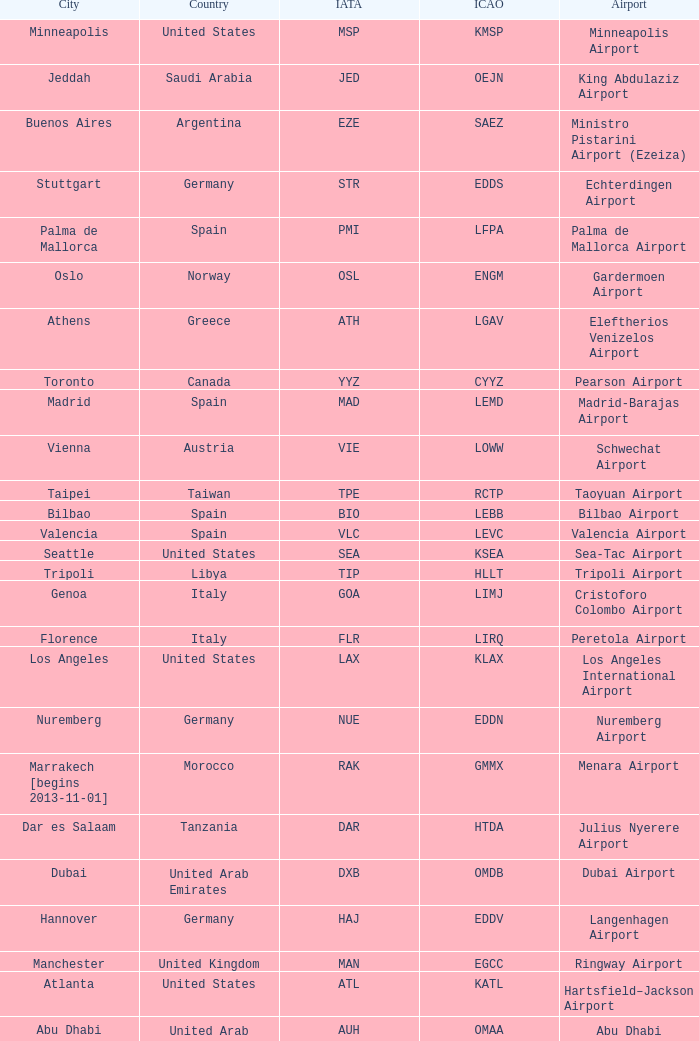Parse the full table. {'header': ['City', 'Country', 'IATA', 'ICAO', 'Airport'], 'rows': [['Minneapolis', 'United States', 'MSP', 'KMSP', 'Minneapolis Airport'], ['Jeddah', 'Saudi Arabia', 'JED', 'OEJN', 'King Abdulaziz Airport'], ['Buenos Aires', 'Argentina', 'EZE', 'SAEZ', 'Ministro Pistarini Airport (Ezeiza)'], ['Stuttgart', 'Germany', 'STR', 'EDDS', 'Echterdingen Airport'], ['Palma de Mallorca', 'Spain', 'PMI', 'LFPA', 'Palma de Mallorca Airport'], ['Oslo', 'Norway', 'OSL', 'ENGM', 'Gardermoen Airport'], ['Athens', 'Greece', 'ATH', 'LGAV', 'Eleftherios Venizelos Airport'], ['Toronto', 'Canada', 'YYZ', 'CYYZ', 'Pearson Airport'], ['Madrid', 'Spain', 'MAD', 'LEMD', 'Madrid-Barajas Airport'], ['Vienna', 'Austria', 'VIE', 'LOWW', 'Schwechat Airport'], ['Taipei', 'Taiwan', 'TPE', 'RCTP', 'Taoyuan Airport'], ['Bilbao', 'Spain', 'BIO', 'LEBB', 'Bilbao Airport'], ['Valencia', 'Spain', 'VLC', 'LEVC', 'Valencia Airport'], ['Seattle', 'United States', 'SEA', 'KSEA', 'Sea-Tac Airport'], ['Tripoli', 'Libya', 'TIP', 'HLLT', 'Tripoli Airport'], ['Genoa', 'Italy', 'GOA', 'LIMJ', 'Cristoforo Colombo Airport'], ['Florence', 'Italy', 'FLR', 'LIRQ', 'Peretola Airport'], ['Los Angeles', 'United States', 'LAX', 'KLAX', 'Los Angeles International Airport'], ['Nuremberg', 'Germany', 'NUE', 'EDDN', 'Nuremberg Airport'], ['Marrakech [begins 2013-11-01]', 'Morocco', 'RAK', 'GMMX', 'Menara Airport'], ['Dar es Salaam', 'Tanzania', 'DAR', 'HTDA', 'Julius Nyerere Airport'], ['Dubai', 'United Arab Emirates', 'DXB', 'OMDB', 'Dubai Airport'], ['Hannover', 'Germany', 'HAJ', 'EDDV', 'Langenhagen Airport'], ['Manchester', 'United Kingdom', 'MAN', 'EGCC', 'Ringway Airport'], ['Atlanta', 'United States', 'ATL', 'KATL', 'Hartsfield–Jackson Airport'], ['Abu Dhabi', 'United Arab Emirates', 'AUH', 'OMAA', 'Abu Dhabi Airport'], ['Benghazi', 'Libya', 'BEN', 'HLLB', 'Benina Airport'], ['Turin', 'Italy', 'TRN', 'LIMF', 'Sandro Pertini Airport'], ['Delhi', 'India', 'DEL', 'VIDP', 'Indira Gandhi Airport'], ['Ho Chi Minh City', 'Vietnam', 'SGN', 'VVTS', 'Tan Son Nhat Airport'], ['Jakarta', 'Indonesia', 'CGK', 'WIII', 'Soekarno–Hatta Airport'], ['London', 'United Kingdom', 'LCY', 'EGLC', 'City Airport'], ['Libreville', 'Gabon', 'LBV', 'FOOL', "Leon M'ba Airport"], ['Nairobi', 'Kenya', 'NBO', 'HKJK', 'Jomo Kenyatta Airport'], ['Tel Aviv', 'Israel', 'TLV', 'LLBG', 'Ben Gurion Airport'], ['Dublin', 'Ireland', 'DUB', 'EIDW', 'Dublin Airport'], ['Bucharest', 'Romania', 'OTP', 'LROP', 'Otopeni Airport'], ['Moscow', 'Russia', 'DME', 'UUDD', 'Domodedovo Airport'], ['Porto', 'Portugal', 'OPO', 'LPPR', 'Francisco de Sa Carneiro Airport'], ['Mumbai', 'India', 'BOM', 'VABB', 'Chhatrapati Shivaji Airport'], ['Saint Petersburg', 'Russia', 'LED', 'ULLI', 'Pulkovo Airport'], ['New York City', 'United States', 'JFK', 'KJFK', 'John F Kennedy Airport'], ['Venice', 'Italy', 'VCE', 'LIPZ', 'Marco Polo Airport'], ['Prague', 'Czech Republic', 'PRG', 'LKPR', 'Ruzyně Airport'], ['Newark', 'United States', 'EWR', 'KEWR', 'Liberty Airport'], ['Malaga', 'Spain', 'AGP', 'LEMG', 'Málaga-Costa del Sol Airport'], ['Hamburg', 'Germany', 'HAM', 'EDDH', 'Fuhlsbüttel Airport'], ['Brussels', 'Belgium', 'BRU', 'EBBR', 'Brussels Airport'], ['Lyon', 'France', 'LYS', 'LFLL', 'Saint-Exupéry Airport'], ['Johannesburg', 'South Africa', 'JNB', 'FAJS', 'OR Tambo Airport'], ['Frankfurt', 'Germany', 'FRA', 'EDDF', 'Frankfurt am Main Airport'], ['Munich', 'Germany', 'MUC', 'EDDM', 'Franz Josef Strauss Airport'], ['Basel Mulhouse Freiburg', 'Switzerland France Germany', 'BSL MLH EAP', 'LFSB', 'Euro Airport'], ['Zurich', 'Switzerland', 'ZRH', 'LSZH', 'Zurich Airport'], ['Cairo', 'Egypt', 'CAI', 'HECA', 'Cairo Airport'], ['Thessaloniki', 'Greece', 'SKG', 'LGTS', 'Macedonia Airport'], ['Riga', 'Latvia', 'RIX', 'EVRA', 'Riga Airport'], ['Yerevan', 'Armenia', 'EVN', 'UDYZ', 'Zvartnots Airport'], ['Düsseldorf', 'Germany', 'DUS', 'EDDL', 'Lohausen Airport'], ['Tehran', 'Iran', 'IKA', 'OIIE', 'Imam Khomeini Airport'], ['Nice', 'France', 'NCE', 'LFMN', "Côte d'Azur Airport"], ['Douala', 'Cameroon', 'DLA', 'FKKD', 'Douala Airport'], ['Birmingham', 'United Kingdom', 'BHX', 'EGBB', 'Birmingham Airport'], ['Rome', 'Italy', 'FCO', 'LIRF', 'Leonardo da Vinci Airport'], ['Boston', 'United States', 'BOS', 'KBOS', 'Logan Airport'], ['Manila', 'Philippines', 'MNL', 'RPLL', 'Ninoy Aquino Airport'], ['Singapore', 'Singapore', 'SIN', 'WSSS', 'Changi Airport'], ['Copenhagen', 'Denmark', 'CPH', 'EKCH', 'Kastrup Airport'], ['Sarajevo', 'Bosnia and Herzegovina', 'SJJ', 'LQSA', 'Butmir Airport'], ['Bangkok', 'Thailand', 'BKK', 'VTBS', 'Suvarnabhumi Airport'], ['Gothenburg [begins 2013-12-14]', 'Sweden', 'GOT', 'ESGG', 'Gothenburg-Landvetter Airport'], ['Skopje', 'Republic of Macedonia', 'SKP', 'LWSK', 'Alexander the Great Airport'], ['Berlin', 'Germany', 'TXL', 'EDDT', 'Tegel Airport'], ['Lisbon', 'Portugal', 'LIS', 'LPPT', 'Portela Airport'], ['Tunis', 'Tunisia', 'TUN', 'DTTA', 'Carthage Airport'], ['London [begins 2013-12-14]', 'United Kingdom', 'LGW', 'EGKK', 'Gatwick Airport'], ['Geneva', 'Switzerland', 'GVA', 'LSGG', 'Cointrin Airport'], ['Lugano', 'Switzerland', 'LUG', 'LSZA', 'Agno Airport'], ['Sofia', 'Bulgaria', 'SOF', 'LBSF', 'Vrazhdebna Airport'], ['Kiev', 'Ukraine', 'KBP', 'UKBB', 'Boryspil International Airport'], ['Warsaw', 'Poland', 'WAW', 'EPWA', 'Frederic Chopin Airport'], ['Tokyo', 'Japan', 'NRT', 'RJAA', 'Narita Airport'], ['Tirana', 'Albania', 'TIA', 'LATI', 'Nënë Tereza Airport'], ['Budapest', 'Hungary', 'BUD', 'LHBP', 'Ferihegy Airport'], ['Washington DC', 'United States', 'IAD', 'KIAD', 'Dulles Airport'], ['San Francisco', 'United States', 'SFO', 'KSFO', 'San Francisco Airport'], ['London', 'United Kingdom', 'LHR', 'EGLL', 'Heathrow Airport'], ['Lagos', 'Nigeria', 'LOS', 'DNMM', 'Murtala Muhammed Airport'], ['Beirut', 'Lebanon', 'BEY', 'OLBA', 'Rafic Hariri Airport'], ['Beijing', 'China', 'PEK', 'ZBAA', 'Capital Airport'], ['Amsterdam', 'Netherlands', 'AMS', 'EHAM', 'Amsterdam Airport Schiphol'], ['Luxembourg City', 'Luxembourg', 'LUX', 'ELLX', 'Findel Airport'], ['Shanghai', 'China', 'PVG', 'ZSPD', 'Pudong Airport'], ['Caracas', 'Venezuela', 'CCS', 'SVMI', 'Simón Bolívar Airport'], ['Paris', 'France', 'CDG', 'LFPG', 'Charles de Gaulle Airport'], ['Riyadh', 'Saudi Arabia', 'RUH', 'OERK', 'King Khalid Airport'], ['Santiago', 'Chile', 'SCL', 'SCEL', 'Comodoro Arturo Benitez Airport'], ['Helsinki', 'Finland', 'HEL', 'EFHK', 'Vantaa Airport'], ['Hong Kong', 'Hong Kong', 'HKG', 'VHHH', 'Chek Lap Kok Airport'], ['Miami', 'United States', 'MIA', 'KMIA', 'Miami Airport'], ['Casablanca', 'Morocco', 'CMN', 'GMMN', 'Mohammed V Airport'], ['Rio de Janeiro [resumes 2014-7-14]', 'Brazil', 'GIG', 'SBGL', 'Galeão Airport'], ['Milan', 'Italy', 'MXP', 'LIMC', 'Malpensa Airport'], ['Chicago', 'United States', 'ORD', 'KORD', "O'Hare Airport"], ['Accra', 'Ghana', 'ACC', 'DGAA', 'Kotoka Airport'], ['Muscat', 'Oman', 'MCT', 'OOMS', 'Seeb Airport'], ['Istanbul', 'Turkey', 'IST', 'LTBA', 'Atatürk Airport'], ['Yaounde', 'Cameroon', 'NSI', 'FKYS', 'Yaounde Nsimalen Airport'], ['São Paulo', 'Brazil', 'GRU', 'SBGR', 'Guarulhos Airport'], ['Barcelona', 'Spain', 'BCN', 'LEBL', 'Barcelona-El Prat Airport'], ['Malabo', 'Equatorial Guinea', 'SSG', 'FGSL', 'Saint Isabel Airport'], ['Belgrade', 'Serbia', 'BEG', 'LYBE', 'Nikola Tesla Airport'], ['Stockholm', 'Sweden', 'ARN', 'ESSA', 'Arlanda Airport'], ['Montreal', 'Canada', 'YUL', 'CYUL', 'Pierre Elliott Trudeau Airport'], ['Karachi', 'Pakistan', 'KHI', 'OPKC', 'Jinnah Airport']]} What is the ICAO of Douala city? FKKD. 